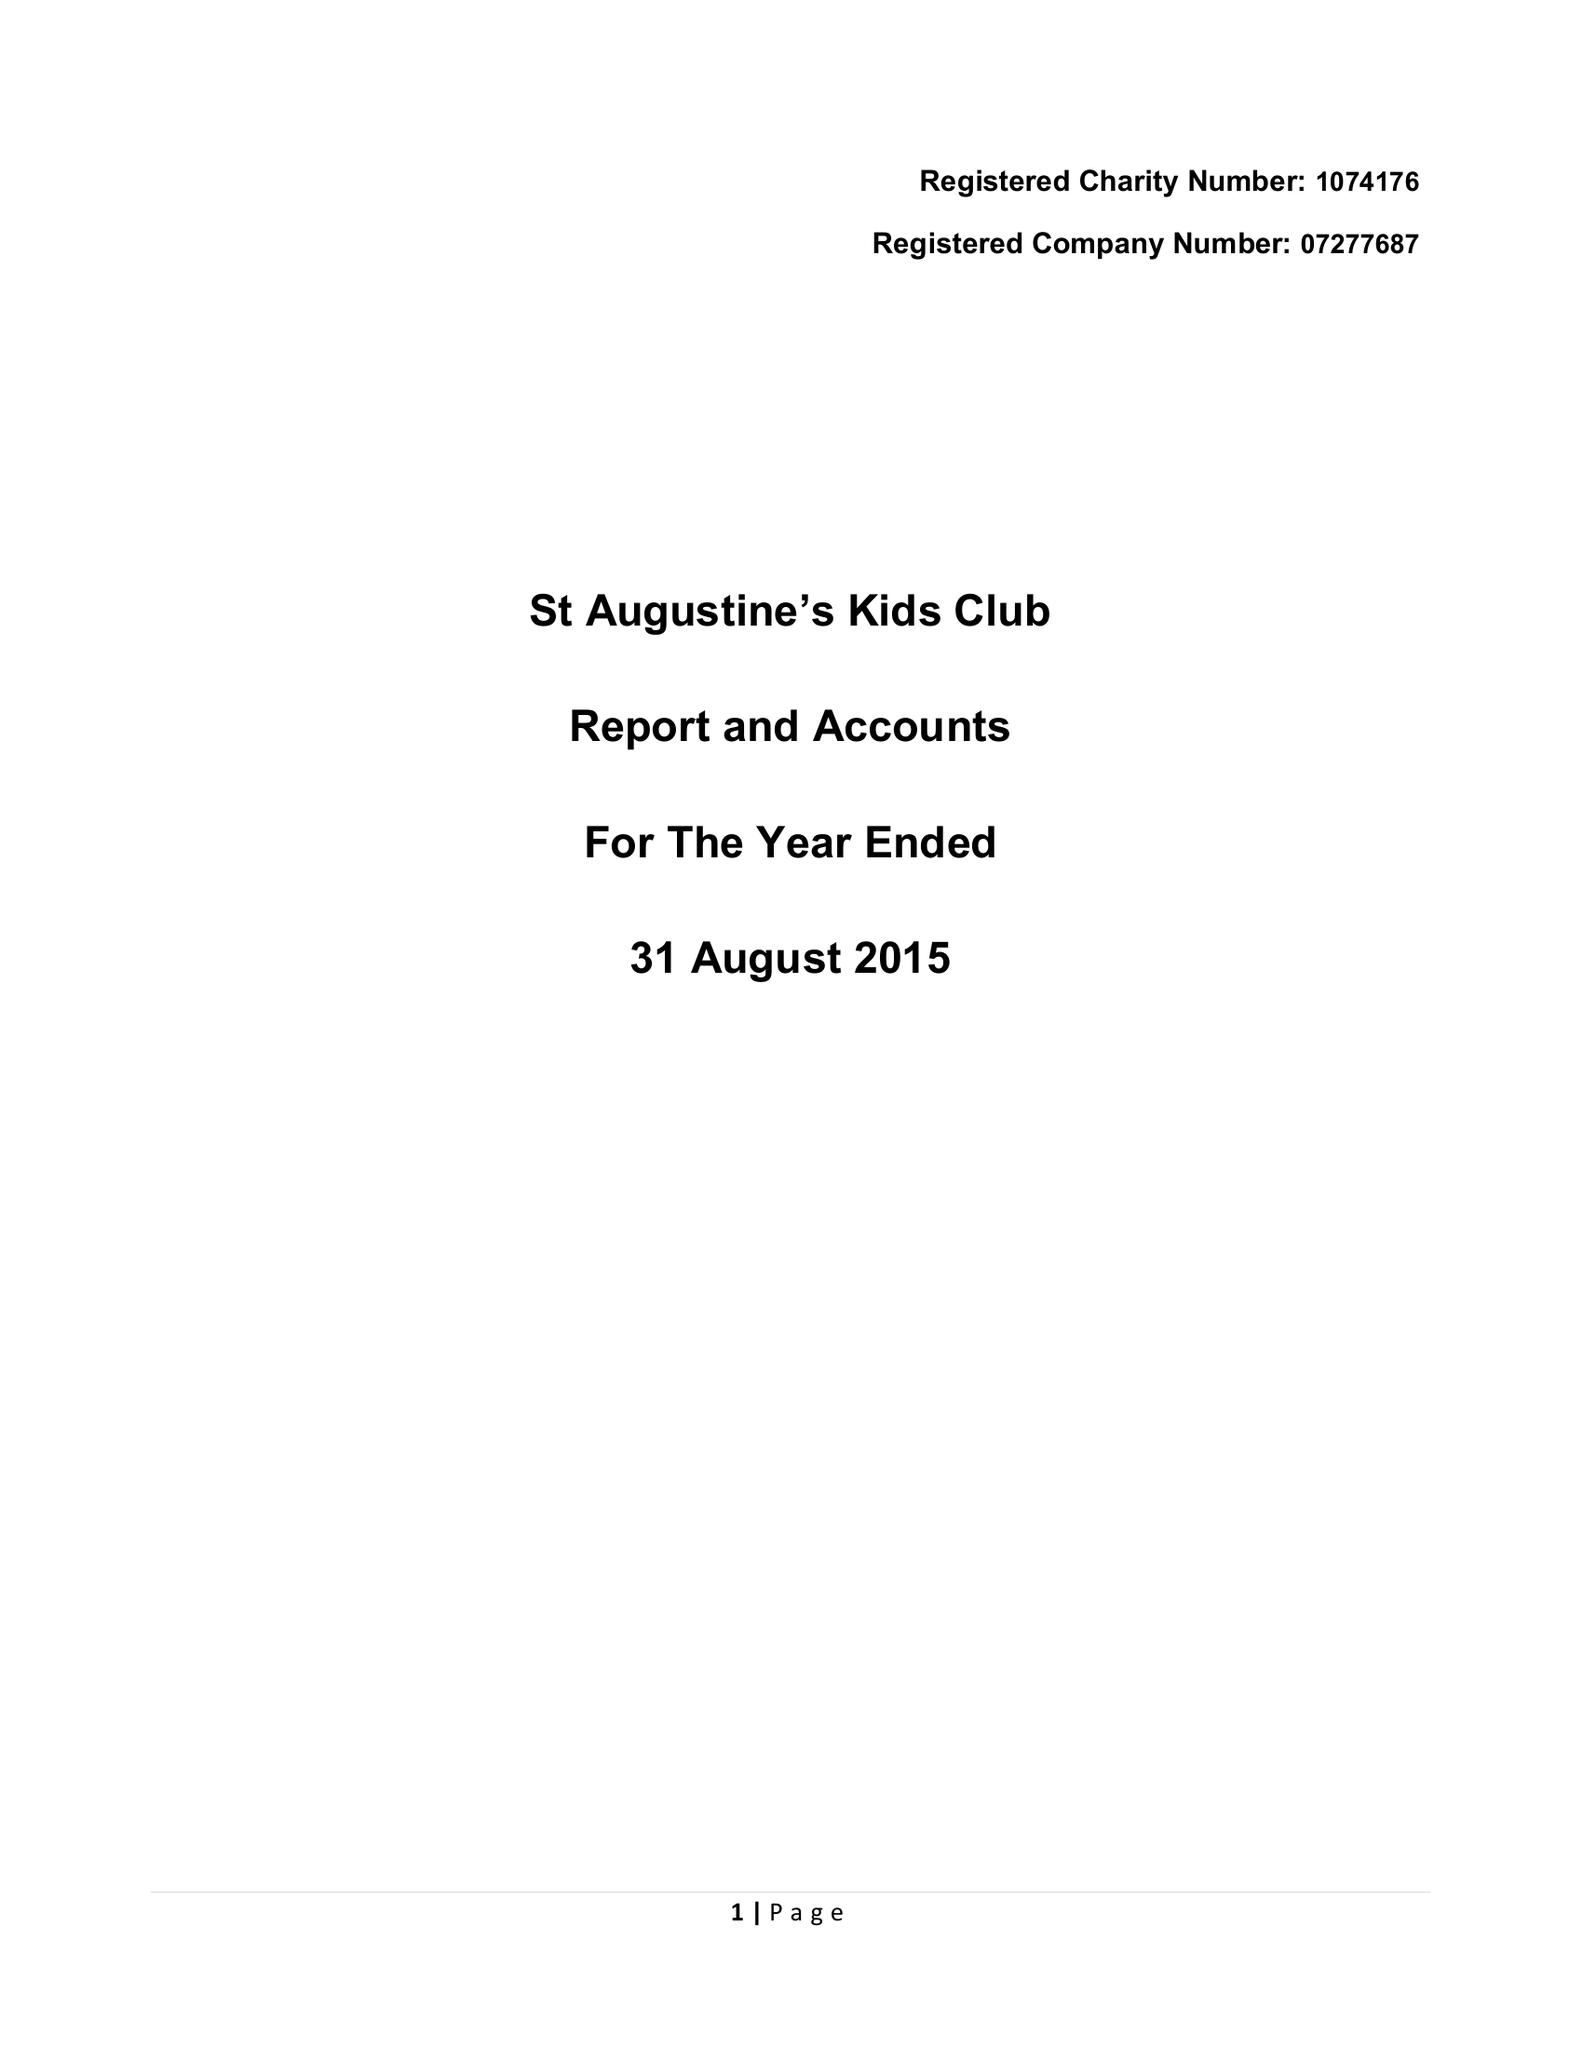What is the value for the address__street_line?
Answer the question using a single word or phrase. HOLLIS LANE 